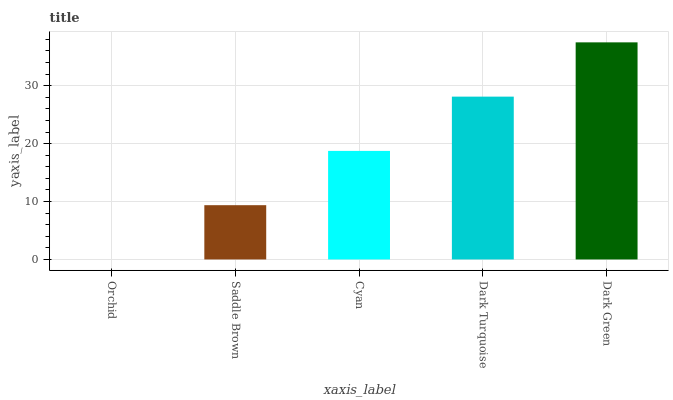Is Orchid the minimum?
Answer yes or no. Yes. Is Dark Green the maximum?
Answer yes or no. Yes. Is Saddle Brown the minimum?
Answer yes or no. No. Is Saddle Brown the maximum?
Answer yes or no. No. Is Saddle Brown greater than Orchid?
Answer yes or no. Yes. Is Orchid less than Saddle Brown?
Answer yes or no. Yes. Is Orchid greater than Saddle Brown?
Answer yes or no. No. Is Saddle Brown less than Orchid?
Answer yes or no. No. Is Cyan the high median?
Answer yes or no. Yes. Is Cyan the low median?
Answer yes or no. Yes. Is Dark Green the high median?
Answer yes or no. No. Is Saddle Brown the low median?
Answer yes or no. No. 